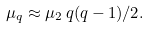<formula> <loc_0><loc_0><loc_500><loc_500>\mu _ { q } \approx \mu _ { 2 } \, q ( q - 1 ) / 2 .</formula> 